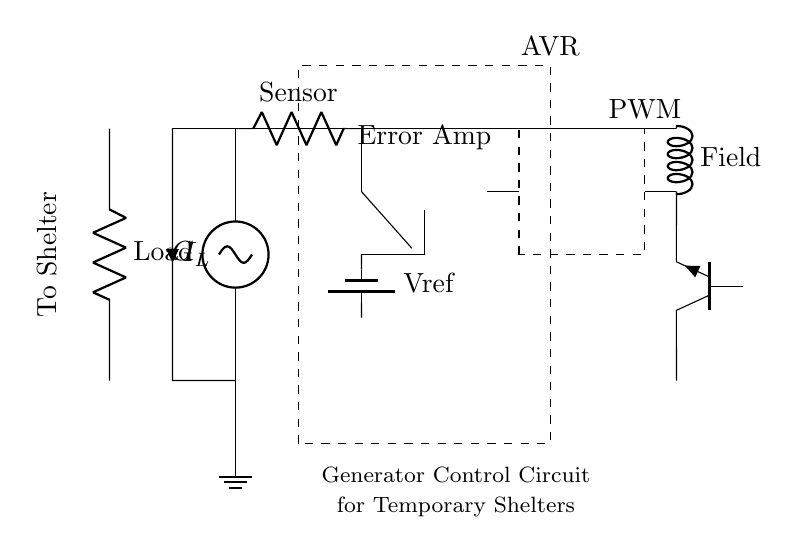What is the main function of the automatic voltage regulator? The function of the automatic voltage regulator is to maintain a stable voltage output from the generator by adjusting the field current in response to changes in load conditions.
Answer: Stable voltage output What type of transistor is used in this circuit? The circuit shows an NPN type transistor, which is used for switching applications to control the current to the field winding.
Answer: NPN How does the reference voltage get into the error amplifier? The reference voltage is supplied from a battery connected to the input of the error amplifier, allowing it to compare the sensor voltage with this fixed reference.
Answer: Through a battery What component supplies the field winding with current? The power transistor provides current to the field winding based on the pulse width modulation signal from the PWM controller.
Answer: Power transistor What is the role of the PWM controller in this circuit? The PWM controller generates a variable duty cycle signal to control the amount of voltage and current sent to the field winding, helping stabilize the output voltage.
Answer: Control field winding current How does the voltage sensor relate to the load? The voltage sensor monitors the output voltage to ensure it remains within desired limits by feeding that information to the error amplifier for adjustment.
Answer: Monitors output voltage What type of load is indicated in the circuit? The load is indicated as a resistor in the circuit diagram, representing the electrical devices present in the shelter reliant on the generator for power.
Answer: Resistor 